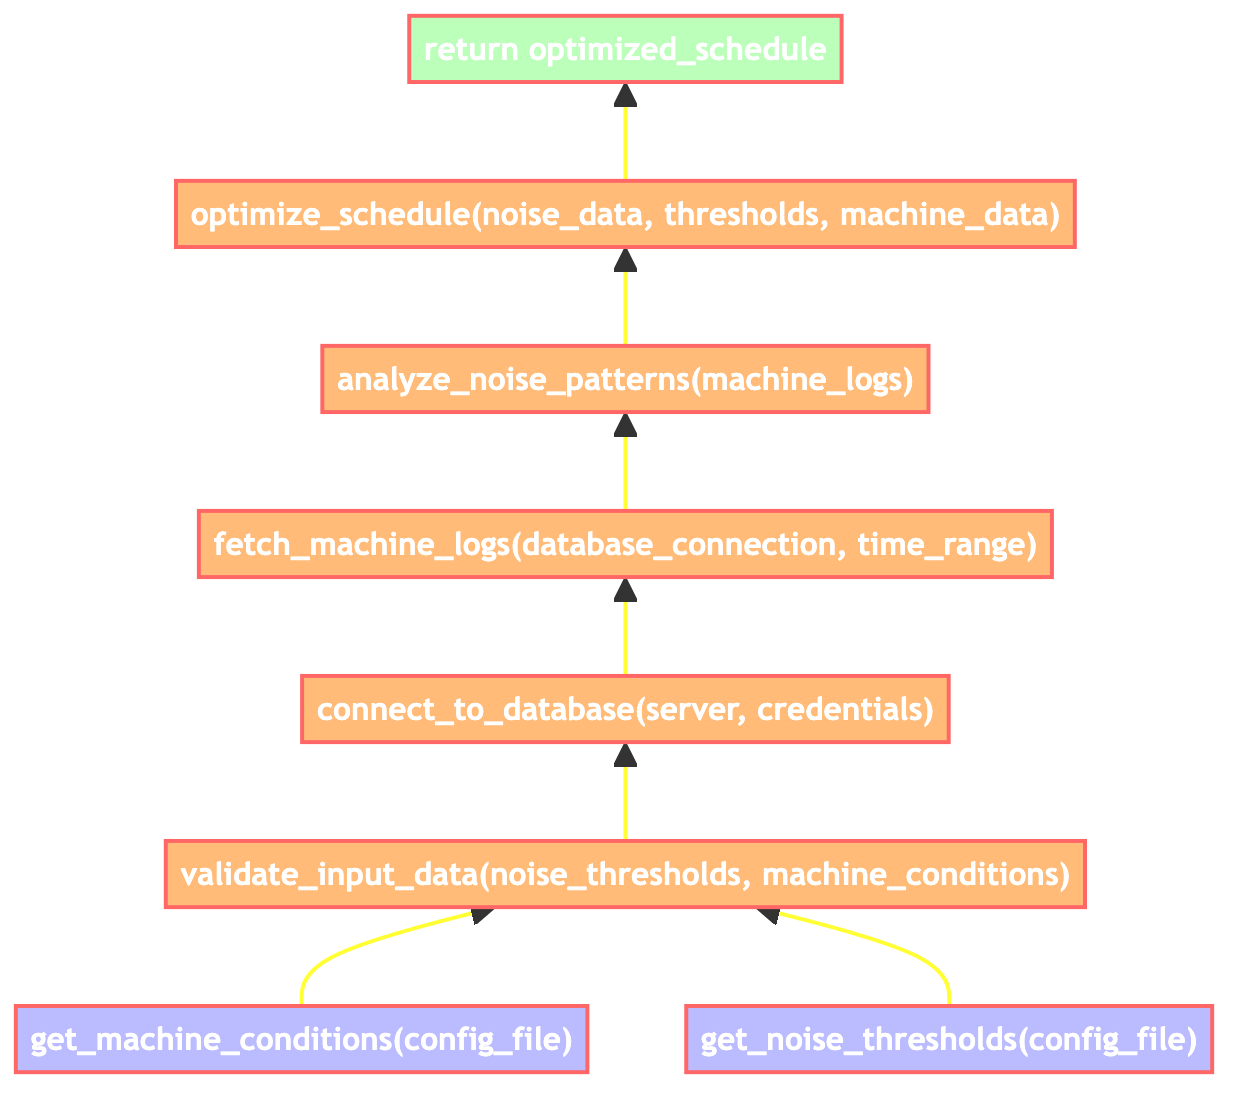what is the first step in the process? The first step is getting machine conditions from the configuration file, represented by the node 'get_machine_conditions(config_file)' which is at the bottom of the flowchart.
Answer: get_machine_conditions(config_file) how many input nodes are there in the flowchart? There are two input nodes in the flowchart, which are 'get_machine_conditions(config_file)' and 'get_noise_thresholds(config_file)'.
Answer: 2 what is the output of the flowchart? The output is generated by the last step in the flowchart, which indicates it returns the optimized maintenance schedule. This is represented in the diagram as 'return optimized_schedule'.
Answer: return optimized_schedule which node precedes the 'connect_to_database' step? Before 'connect_to_database', the 'validate_input_data' step is performed, indicating a direct flow from validation to database connection.
Answer: validate_input_data(noise_thresholds, machine_conditions) what does the 'analyze_noise_patterns' node depend on? The 'analyze_noise_patterns' node relies on the output from the 'fetch_machine_logs' node, indicating that historical machine logs must be retrieved before analysis.
Answer: fetch_machine_logs(database_connection, time_range) what is required before generating the maintenance schedule? Before generating the maintenance schedule, noise data must be analyzed, which is dependent on the historical machine logs fetched previously. This establishes a critical path for the optimization process.
Answer: analyze_noise_patterns(machine_logs) how does 'validate_input_data' contribute to the workflow? The 'validate_input_data' step ensures that the noise thresholds and machine conditions are accurate and appropriate before proceeding to connect to the database, which is crucial for reliable data analysis later in the workflow.
Answer: Ensures data accuracy what is the relationship between 'connect_to_database' and 'fetch_machine_logs'? 'connect_to_database' must be completed first before 'fetch_machine_logs' can occur, establishing a sequential dependency where fetching logs relies on a successful database connection.
Answer: Sequential dependency what information is retrieved from the configuration file? The nodes retrieving information from the configuration file are 'get_machine_conditions' and 'get_noise_thresholds', indicating that both types of thresholds and conditions necessary for validation are sourced from the config file.
Answer: noise thresholds and machine conditions 